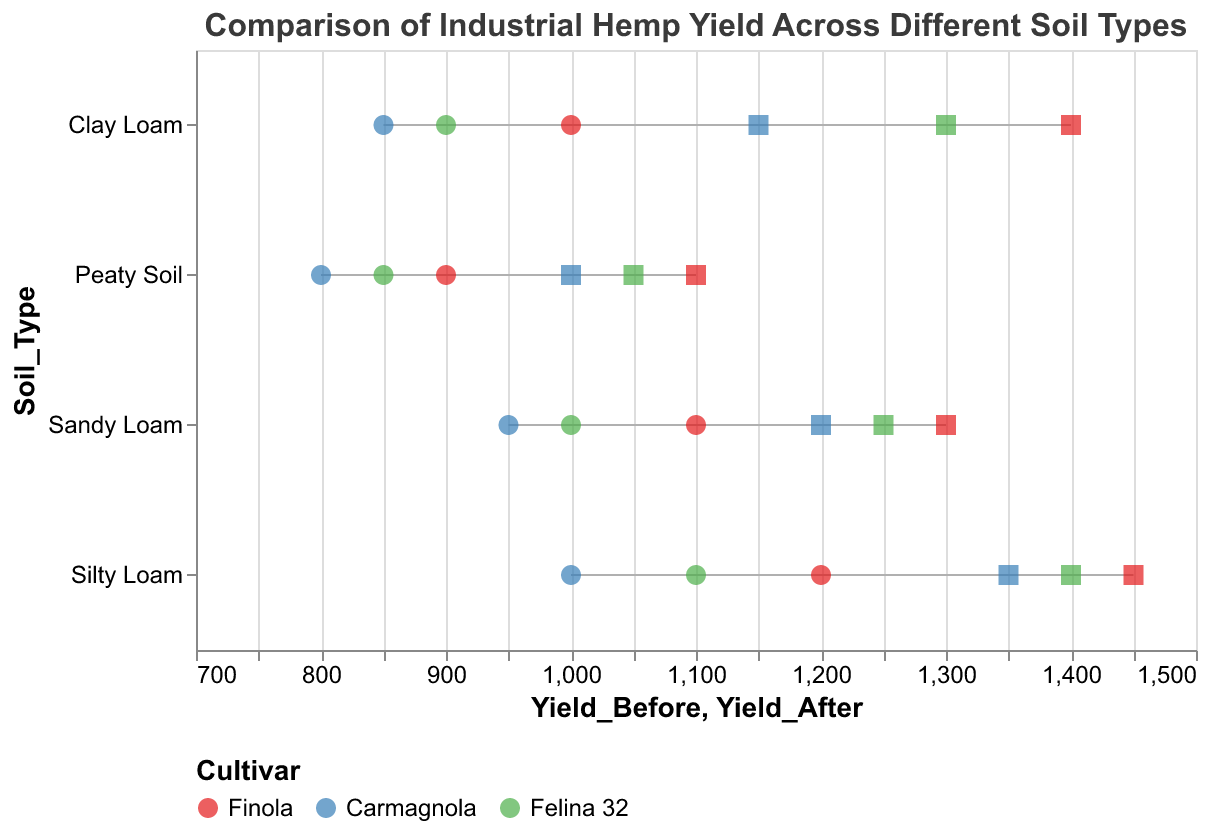What is the title of the plot? The title is displayed at the top of the figure in larger font size, which reads "Comparison of Industrial Hemp Yield Across Different Soil Types".
Answer: Comparison of Industrial Hemp Yield Across Different Soil Types Which soil type exhibited the highest yield after cultivation for all cultivars? By examining the "Yield_After" points (squares) for each soil type, Silty Loam exhibits the highest yields for all cultivars (Finola: 1450, Carmagnola: 1350, Felina 32: 1400).
Answer: Silty Loam What is the yield difference for Finola between before and after cultivation in Clay Loam soil? The yield before cultivation for Finola in Clay Loam is 1000 kg/ha. The yield after cultivation is 1400 kg/ha. The difference is 1400 - 1000 = 400 kg/ha.
Answer: 400 kg/ha Which cultivar shows the greatest increase in yield on Peaty Soil? By comparing both the yield before and after for each cultivar on Peaty Soil, we see: Finola (200 kg/ha increase), Carmagnola (200 kg/ha increase), and Felina 32 (200 kg/ha increase). Thus, all three cultivars have the same increase.
Answer: All Between Clay Loam and Sandy Loam, which soil type had a higher yield for Finola before cultivation? Checking the "Yield_Before" points (circles) for Finola on both soil types: Clay Loam (1000 kg/ha) and Sandy Loam (1100 kg/ha). Thus, Sandy Loam had the higher yield before cultivation.
Answer: Sandy Loam Does Finola show a higher yield after cultivation on Silty Loam or Sandy Loam? Comparing "Yield_After" values (squares) for Finola on these soil types, we have Silty Loam (1450 kg/ha) and Sandy Loam (1300 kg/ha). Silty Loam has the higher yield.
Answer: Silty Loam Which soil type exhibits the smallest range of yield increases across all cultivars? To determine the range of yield increases, we first calculate the yield increases for each soil type:
- Sandy Loam: Finola (200 kg/ha), Carmagnola (250 kg/ha), Felina 32 (250 kg/ha). Range = 250 - 200 = 50 kg/ha.
- Clay Loam: Finola (400 kg/ha), Carmagnola (300 kg/ha), Felina 32 (400 kg/ha). Range = 400 - 300 = 100 kg/ha.
- Silty Loam: Finola (250 kg/ha), Carmagnola (350 kg/ha), Felina 32 (300 kg/ha). Range = 350 - 250 = 100 kg/ha.
- Peaty Soil: Finola (200 kg/ha), Carmagnola (200 kg/ha), Felina 32 (200 kg/ha). Range = 200 - 200 = 0 kg/ha.
Peaty Soil exhibits the smallest range of yield increases.
Answer: Peaty Soil How many cultivars were evaluated in this study? The legend at the bottom of the plot shows three distinct colors representing different cultivars: Finola, Carmagnola, and Felina 32.
Answer: 3 Which cultivar yielded the most increase in yield on Sandy Loam soil? Checking the difference between "Yield_After" and "Yield_Before" for each cultivar on Sandy Loam:
- Finola: 1300 - 1100 = 200 kg/ha
- Carmagnola: 1200 - 950 = 250 kg/ha
- Felina 32: 1250 - 1000 = 250 kg/ha
Both Carmagnola and Felina 32 yielded the most increase on Sandy Loam.
Answer: Carmagnola and Felina 32 